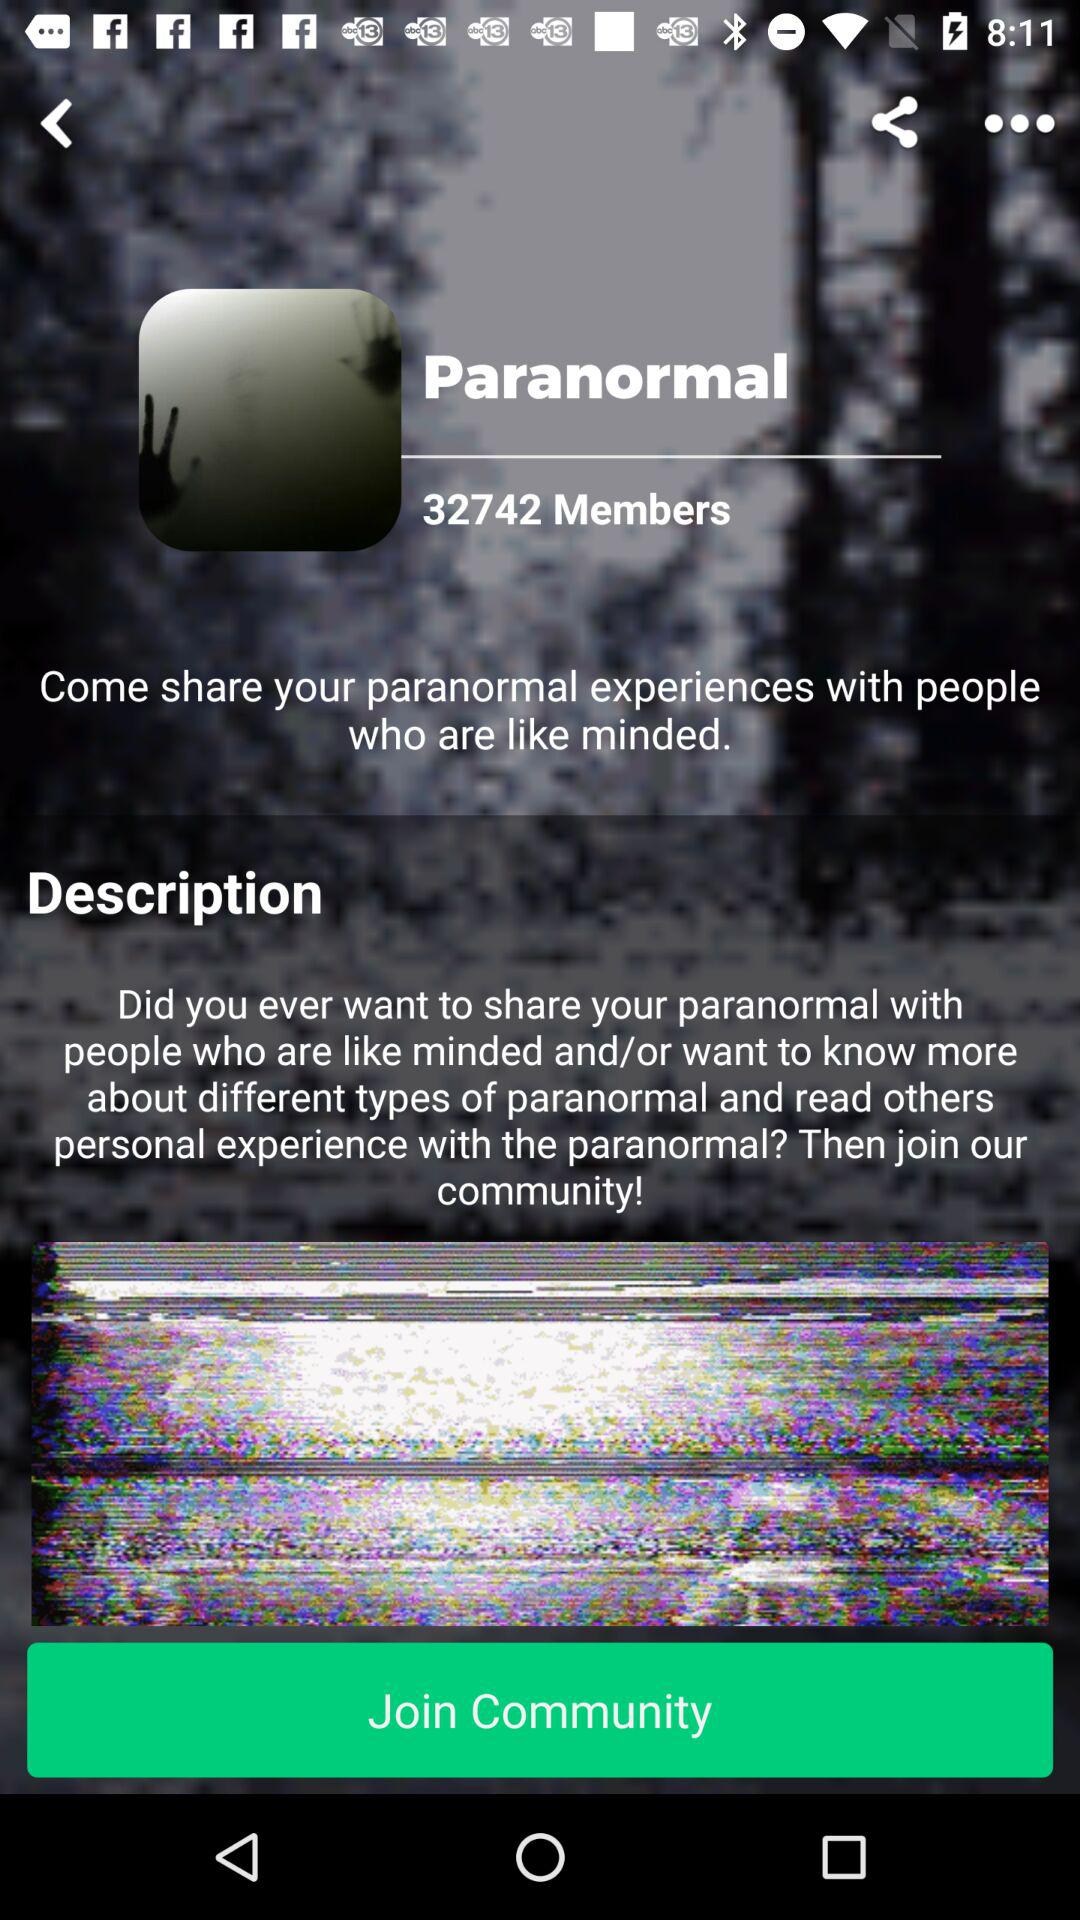What is the number of members in the paranormal community? The number of members in the paranormal community is 32742. 